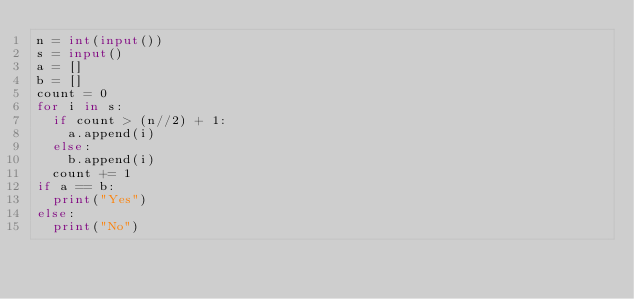Convert code to text. <code><loc_0><loc_0><loc_500><loc_500><_Python_>n = int(input())
s = input()
a = []
b = []
count = 0
for i in s:
  if count > (n//2) + 1:
    a.append(i)
  else:
    b.append(i)
  count += 1
if a == b:
  print("Yes")
else:
  print("No")</code> 